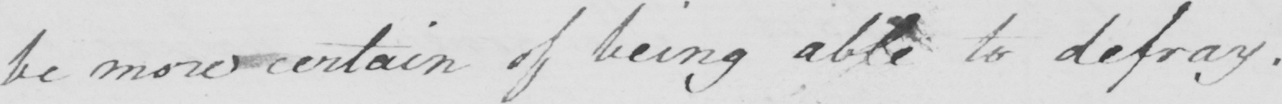Can you read and transcribe this handwriting? be more certain of being able to defray . 